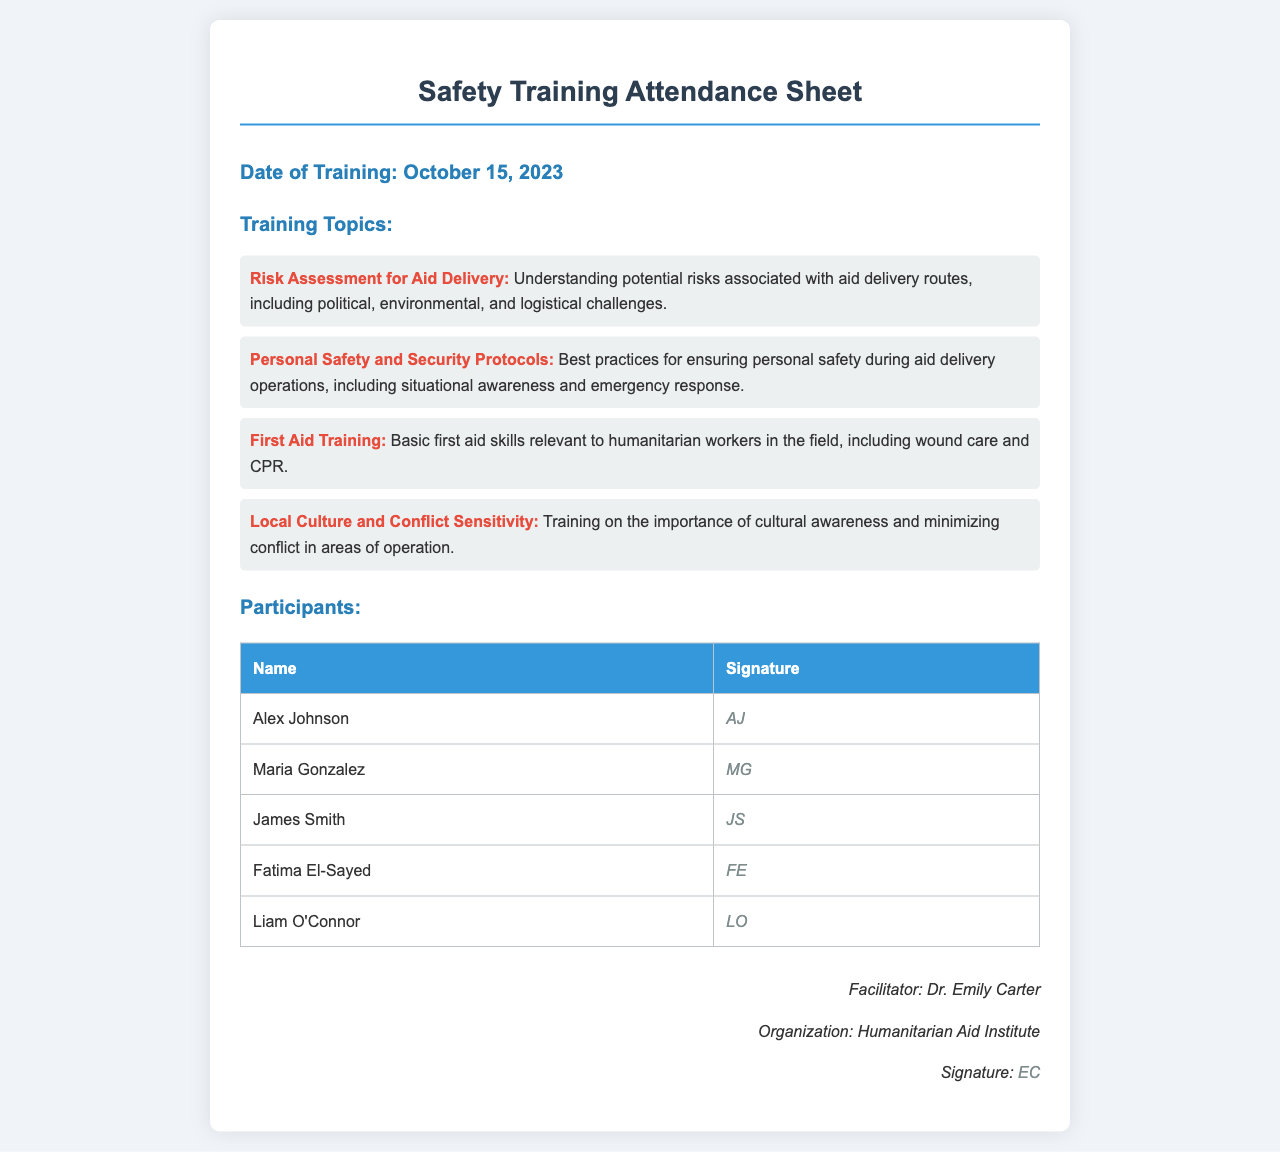What is the date of training? The date of training is specified in the document header under "Date of Training."
Answer: October 15, 2023 How many training topics are covered? The number of training topics is found in the "Training Topics" section by counting the topics listed.
Answer: 4 Who is the facilitator of the training? The facilitator's name is provided in the "facilitator info" section at the bottom of the document.
Answer: Dr. Emily Carter What is one topic covered in the training? One example can be found in the "Training Topics" section where specific topics are listed.
Answer: Risk Assessment for Aid Delivery What is the signature of Maria Gonzalez? The signature for each participant is located in the "Participants" table alongside their names.
Answer: MG List one aspect of personal safety covered in the training. Personal safety topics can be identified in the "Training Topics" section by looking at the relevant training topic description.
Answer: Situational awareness How is the attendance acknowledged? Attendance acknowledgment is reflected by participants providing their signatures next to their names in the document.
Answer: Signatures Which organization conducted the training? The organization is mentioned alongside the facilitator's information at the bottom of the document.
Answer: Humanitarian Aid Institute 